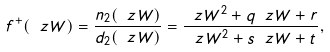<formula> <loc_0><loc_0><loc_500><loc_500>f ^ { + } ( \ z W ) = \frac { n _ { 2 } ( \ z W ) } { d _ { 2 } ( \ z W ) } = \frac { \ z W ^ { 2 } + q \ z W + r } { \ z W ^ { 2 } + s \ z W + t } ,</formula> 